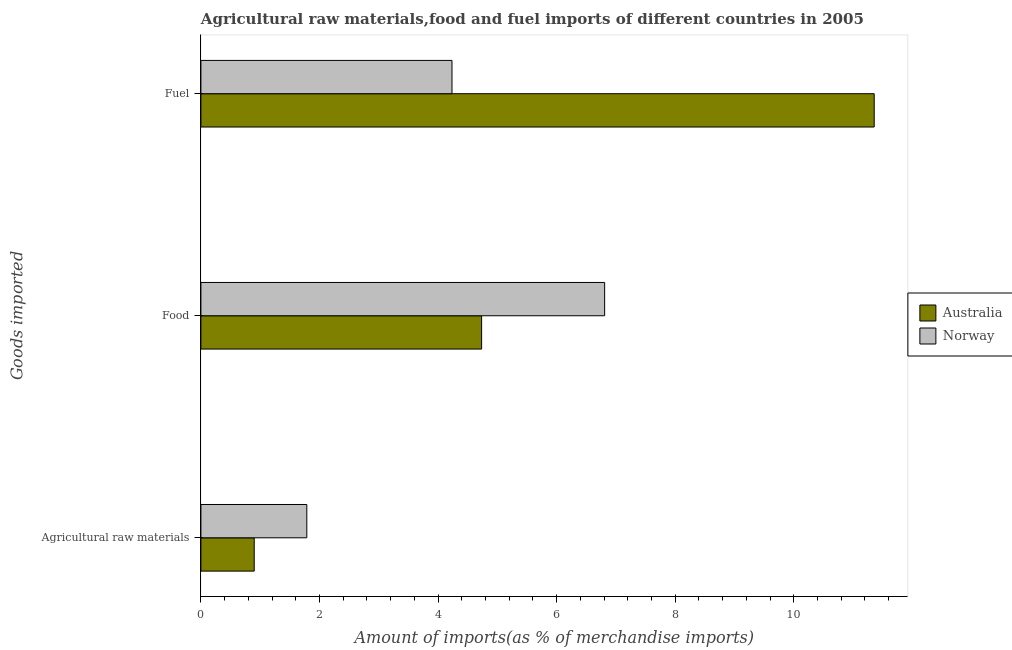How many groups of bars are there?
Your answer should be compact. 3. Are the number of bars per tick equal to the number of legend labels?
Your response must be concise. Yes. Are the number of bars on each tick of the Y-axis equal?
Provide a succinct answer. Yes. What is the label of the 3rd group of bars from the top?
Provide a succinct answer. Agricultural raw materials. What is the percentage of food imports in Norway?
Make the answer very short. 6.81. Across all countries, what is the maximum percentage of raw materials imports?
Provide a succinct answer. 1.79. Across all countries, what is the minimum percentage of fuel imports?
Make the answer very short. 4.24. In which country was the percentage of food imports maximum?
Ensure brevity in your answer.  Norway. What is the total percentage of fuel imports in the graph?
Keep it short and to the point. 15.59. What is the difference between the percentage of food imports in Norway and that in Australia?
Provide a short and direct response. 2.08. What is the difference between the percentage of food imports in Norway and the percentage of fuel imports in Australia?
Offer a very short reply. -4.55. What is the average percentage of fuel imports per country?
Your response must be concise. 7.8. What is the difference between the percentage of food imports and percentage of raw materials imports in Australia?
Offer a terse response. 3.84. What is the ratio of the percentage of fuel imports in Norway to that in Australia?
Ensure brevity in your answer.  0.37. What is the difference between the highest and the second highest percentage of food imports?
Your answer should be very brief. 2.08. What is the difference between the highest and the lowest percentage of fuel imports?
Offer a terse response. 7.12. In how many countries, is the percentage of fuel imports greater than the average percentage of fuel imports taken over all countries?
Ensure brevity in your answer.  1. Is the sum of the percentage of fuel imports in Norway and Australia greater than the maximum percentage of food imports across all countries?
Ensure brevity in your answer.  Yes. What does the 2nd bar from the bottom in Fuel represents?
Give a very brief answer. Norway. How many bars are there?
Ensure brevity in your answer.  6. How many countries are there in the graph?
Ensure brevity in your answer.  2. Are the values on the major ticks of X-axis written in scientific E-notation?
Your answer should be very brief. No. Does the graph contain any zero values?
Your answer should be very brief. No. Does the graph contain grids?
Your response must be concise. No. Where does the legend appear in the graph?
Offer a very short reply. Center right. How many legend labels are there?
Offer a terse response. 2. What is the title of the graph?
Ensure brevity in your answer.  Agricultural raw materials,food and fuel imports of different countries in 2005. Does "Madagascar" appear as one of the legend labels in the graph?
Offer a very short reply. No. What is the label or title of the X-axis?
Your answer should be very brief. Amount of imports(as % of merchandise imports). What is the label or title of the Y-axis?
Give a very brief answer. Goods imported. What is the Amount of imports(as % of merchandise imports) of Australia in Agricultural raw materials?
Make the answer very short. 0.9. What is the Amount of imports(as % of merchandise imports) of Norway in Agricultural raw materials?
Make the answer very short. 1.79. What is the Amount of imports(as % of merchandise imports) of Australia in Food?
Provide a succinct answer. 4.73. What is the Amount of imports(as % of merchandise imports) of Norway in Food?
Offer a very short reply. 6.81. What is the Amount of imports(as % of merchandise imports) of Australia in Fuel?
Give a very brief answer. 11.36. What is the Amount of imports(as % of merchandise imports) of Norway in Fuel?
Your answer should be very brief. 4.24. Across all Goods imported, what is the maximum Amount of imports(as % of merchandise imports) in Australia?
Give a very brief answer. 11.36. Across all Goods imported, what is the maximum Amount of imports(as % of merchandise imports) in Norway?
Your response must be concise. 6.81. Across all Goods imported, what is the minimum Amount of imports(as % of merchandise imports) of Australia?
Ensure brevity in your answer.  0.9. Across all Goods imported, what is the minimum Amount of imports(as % of merchandise imports) of Norway?
Offer a terse response. 1.79. What is the total Amount of imports(as % of merchandise imports) of Australia in the graph?
Your response must be concise. 16.99. What is the total Amount of imports(as % of merchandise imports) in Norway in the graph?
Give a very brief answer. 12.83. What is the difference between the Amount of imports(as % of merchandise imports) of Australia in Agricultural raw materials and that in Food?
Offer a terse response. -3.84. What is the difference between the Amount of imports(as % of merchandise imports) of Norway in Agricultural raw materials and that in Food?
Keep it short and to the point. -5.02. What is the difference between the Amount of imports(as % of merchandise imports) in Australia in Agricultural raw materials and that in Fuel?
Ensure brevity in your answer.  -10.46. What is the difference between the Amount of imports(as % of merchandise imports) in Norway in Agricultural raw materials and that in Fuel?
Keep it short and to the point. -2.45. What is the difference between the Amount of imports(as % of merchandise imports) in Australia in Food and that in Fuel?
Provide a short and direct response. -6.62. What is the difference between the Amount of imports(as % of merchandise imports) in Norway in Food and that in Fuel?
Offer a terse response. 2.58. What is the difference between the Amount of imports(as % of merchandise imports) in Australia in Agricultural raw materials and the Amount of imports(as % of merchandise imports) in Norway in Food?
Provide a succinct answer. -5.91. What is the difference between the Amount of imports(as % of merchandise imports) in Australia in Agricultural raw materials and the Amount of imports(as % of merchandise imports) in Norway in Fuel?
Ensure brevity in your answer.  -3.34. What is the difference between the Amount of imports(as % of merchandise imports) in Australia in Food and the Amount of imports(as % of merchandise imports) in Norway in Fuel?
Ensure brevity in your answer.  0.5. What is the average Amount of imports(as % of merchandise imports) in Australia per Goods imported?
Keep it short and to the point. 5.66. What is the average Amount of imports(as % of merchandise imports) of Norway per Goods imported?
Your answer should be very brief. 4.28. What is the difference between the Amount of imports(as % of merchandise imports) of Australia and Amount of imports(as % of merchandise imports) of Norway in Agricultural raw materials?
Give a very brief answer. -0.89. What is the difference between the Amount of imports(as % of merchandise imports) of Australia and Amount of imports(as % of merchandise imports) of Norway in Food?
Make the answer very short. -2.08. What is the difference between the Amount of imports(as % of merchandise imports) in Australia and Amount of imports(as % of merchandise imports) in Norway in Fuel?
Ensure brevity in your answer.  7.12. What is the ratio of the Amount of imports(as % of merchandise imports) in Australia in Agricultural raw materials to that in Food?
Offer a terse response. 0.19. What is the ratio of the Amount of imports(as % of merchandise imports) of Norway in Agricultural raw materials to that in Food?
Ensure brevity in your answer.  0.26. What is the ratio of the Amount of imports(as % of merchandise imports) of Australia in Agricultural raw materials to that in Fuel?
Provide a succinct answer. 0.08. What is the ratio of the Amount of imports(as % of merchandise imports) in Norway in Agricultural raw materials to that in Fuel?
Make the answer very short. 0.42. What is the ratio of the Amount of imports(as % of merchandise imports) of Australia in Food to that in Fuel?
Your response must be concise. 0.42. What is the ratio of the Amount of imports(as % of merchandise imports) in Norway in Food to that in Fuel?
Give a very brief answer. 1.61. What is the difference between the highest and the second highest Amount of imports(as % of merchandise imports) in Australia?
Your response must be concise. 6.62. What is the difference between the highest and the second highest Amount of imports(as % of merchandise imports) of Norway?
Your answer should be very brief. 2.58. What is the difference between the highest and the lowest Amount of imports(as % of merchandise imports) in Australia?
Make the answer very short. 10.46. What is the difference between the highest and the lowest Amount of imports(as % of merchandise imports) in Norway?
Your answer should be compact. 5.02. 